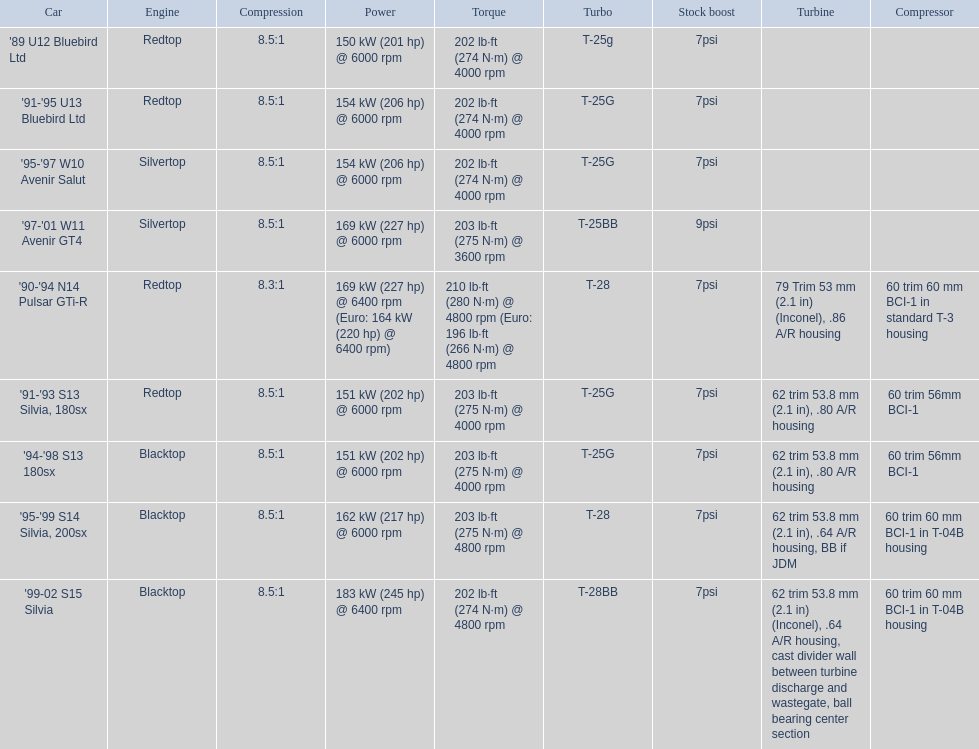What are the noted horsepower numbers for the automobiles? 150 kW (201 hp) @ 6000 rpm, 154 kW (206 hp) @ 6000 rpm, 154 kW (206 hp) @ 6000 rpm, 169 kW (227 hp) @ 6000 rpm, 169 kW (227 hp) @ 6400 rpm (Euro: 164 kW (220 hp) @ 6400 rpm), 151 kW (202 hp) @ 6000 rpm, 151 kW (202 hp) @ 6000 rpm, 162 kW (217 hp) @ 6000 rpm, 183 kW (245 hp) @ 6400 rpm. Which one is the sole car with a horsepower exceeding 230? '99-02 S15 Silvia. 